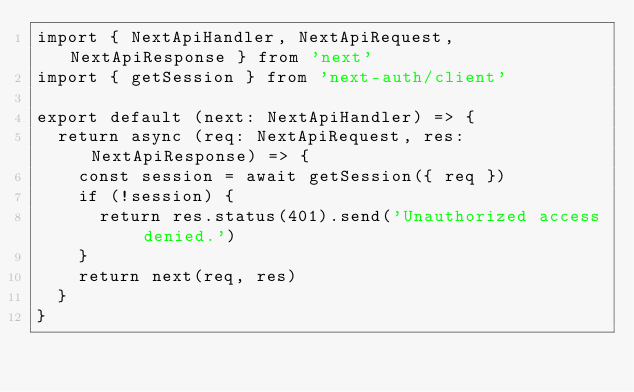Convert code to text. <code><loc_0><loc_0><loc_500><loc_500><_TypeScript_>import { NextApiHandler, NextApiRequest, NextApiResponse } from 'next'
import { getSession } from 'next-auth/client'

export default (next: NextApiHandler) => {
  return async (req: NextApiRequest, res: NextApiResponse) => {
    const session = await getSession({ req })
    if (!session) {
      return res.status(401).send('Unauthorized access denied.')
    }
    return next(req, res)
  }
}
</code> 